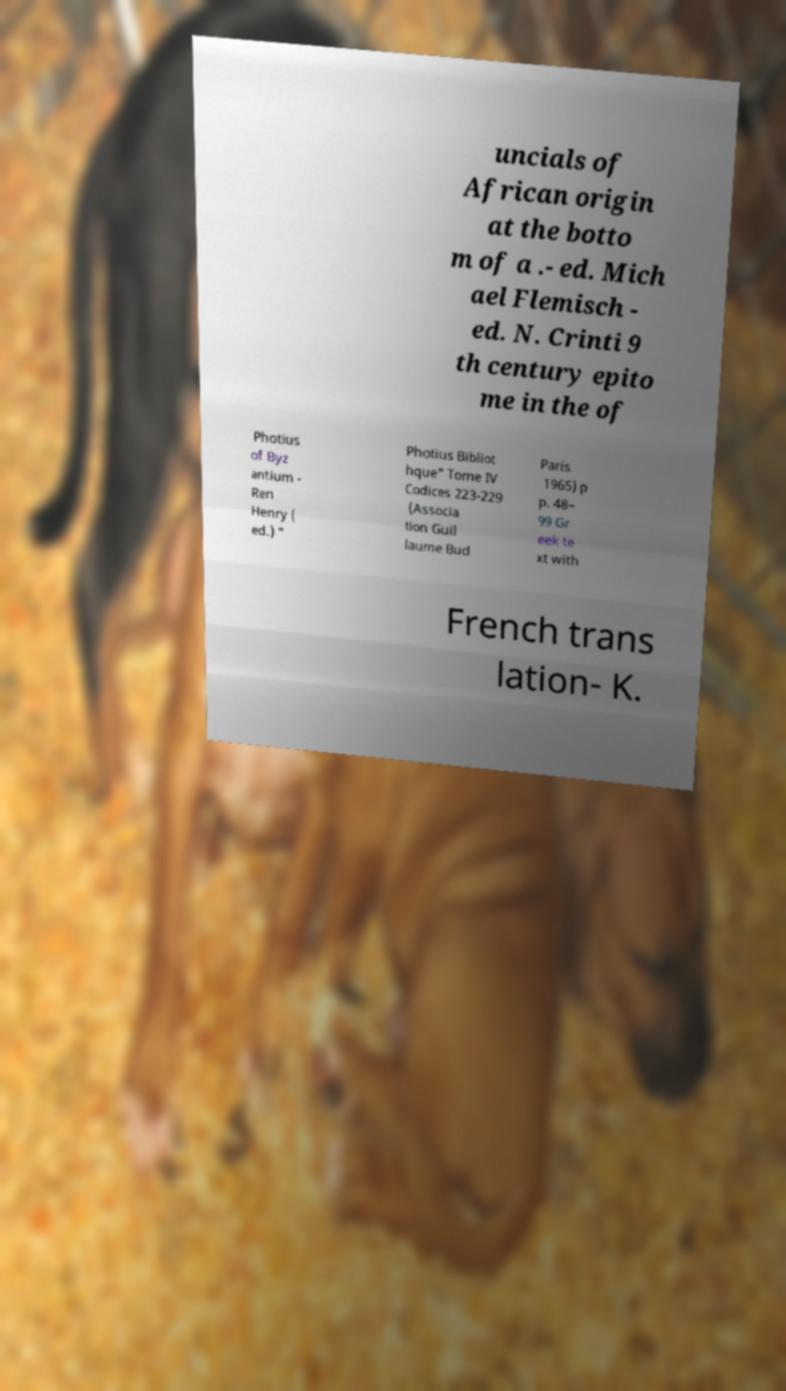Could you assist in decoding the text presented in this image and type it out clearly? uncials of African origin at the botto m of a .- ed. Mich ael Flemisch - ed. N. Crinti 9 th century epito me in the of Photius of Byz antium - Ren Henry ( ed.) " Photius Bibliot hque" Tome IV Codices 223-229 (Associa tion Guil laume Bud Paris 1965) p p. 48– 99 Gr eek te xt with French trans lation- K. 